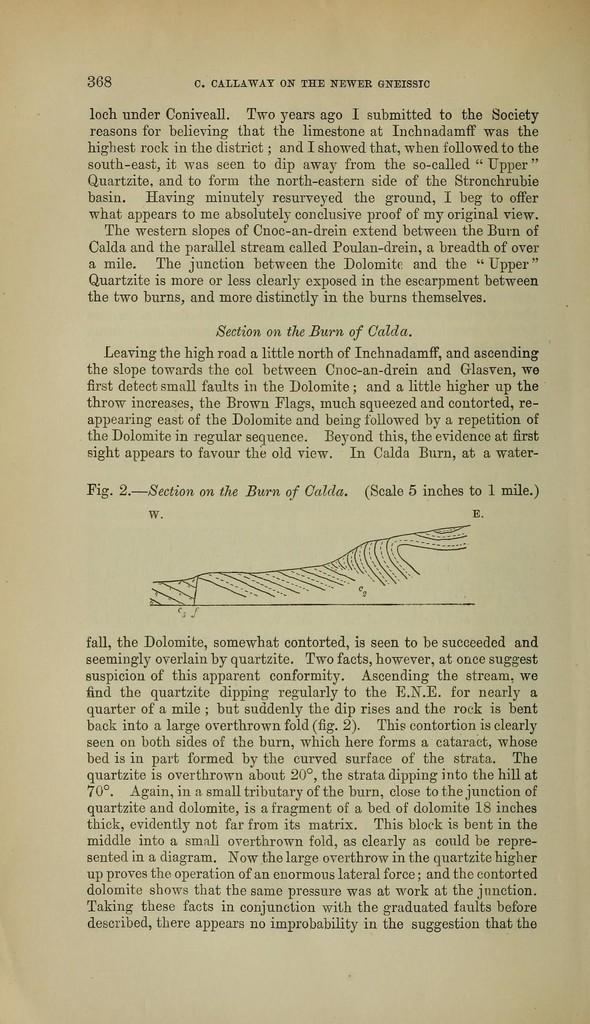What is present in the image that contains written information? There is a paper in the image that contains text. What else can be seen on the paper besides the text? The paper contains a diagram. How many jelly beans are on the paper in the image? There is no mention of jelly beans on the paper in the image. Are the brothers mentioned on the paper in the image? There is no mention of brothers on the paper in the image. Does the paper in the image contain information about the dad? There is no mention of a dad on the paper in the image. 